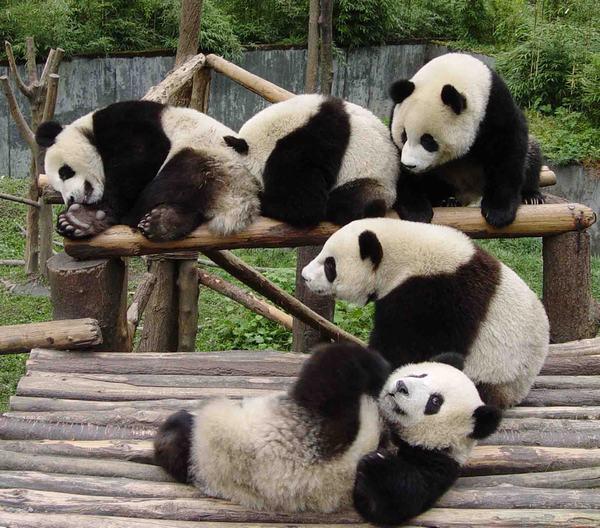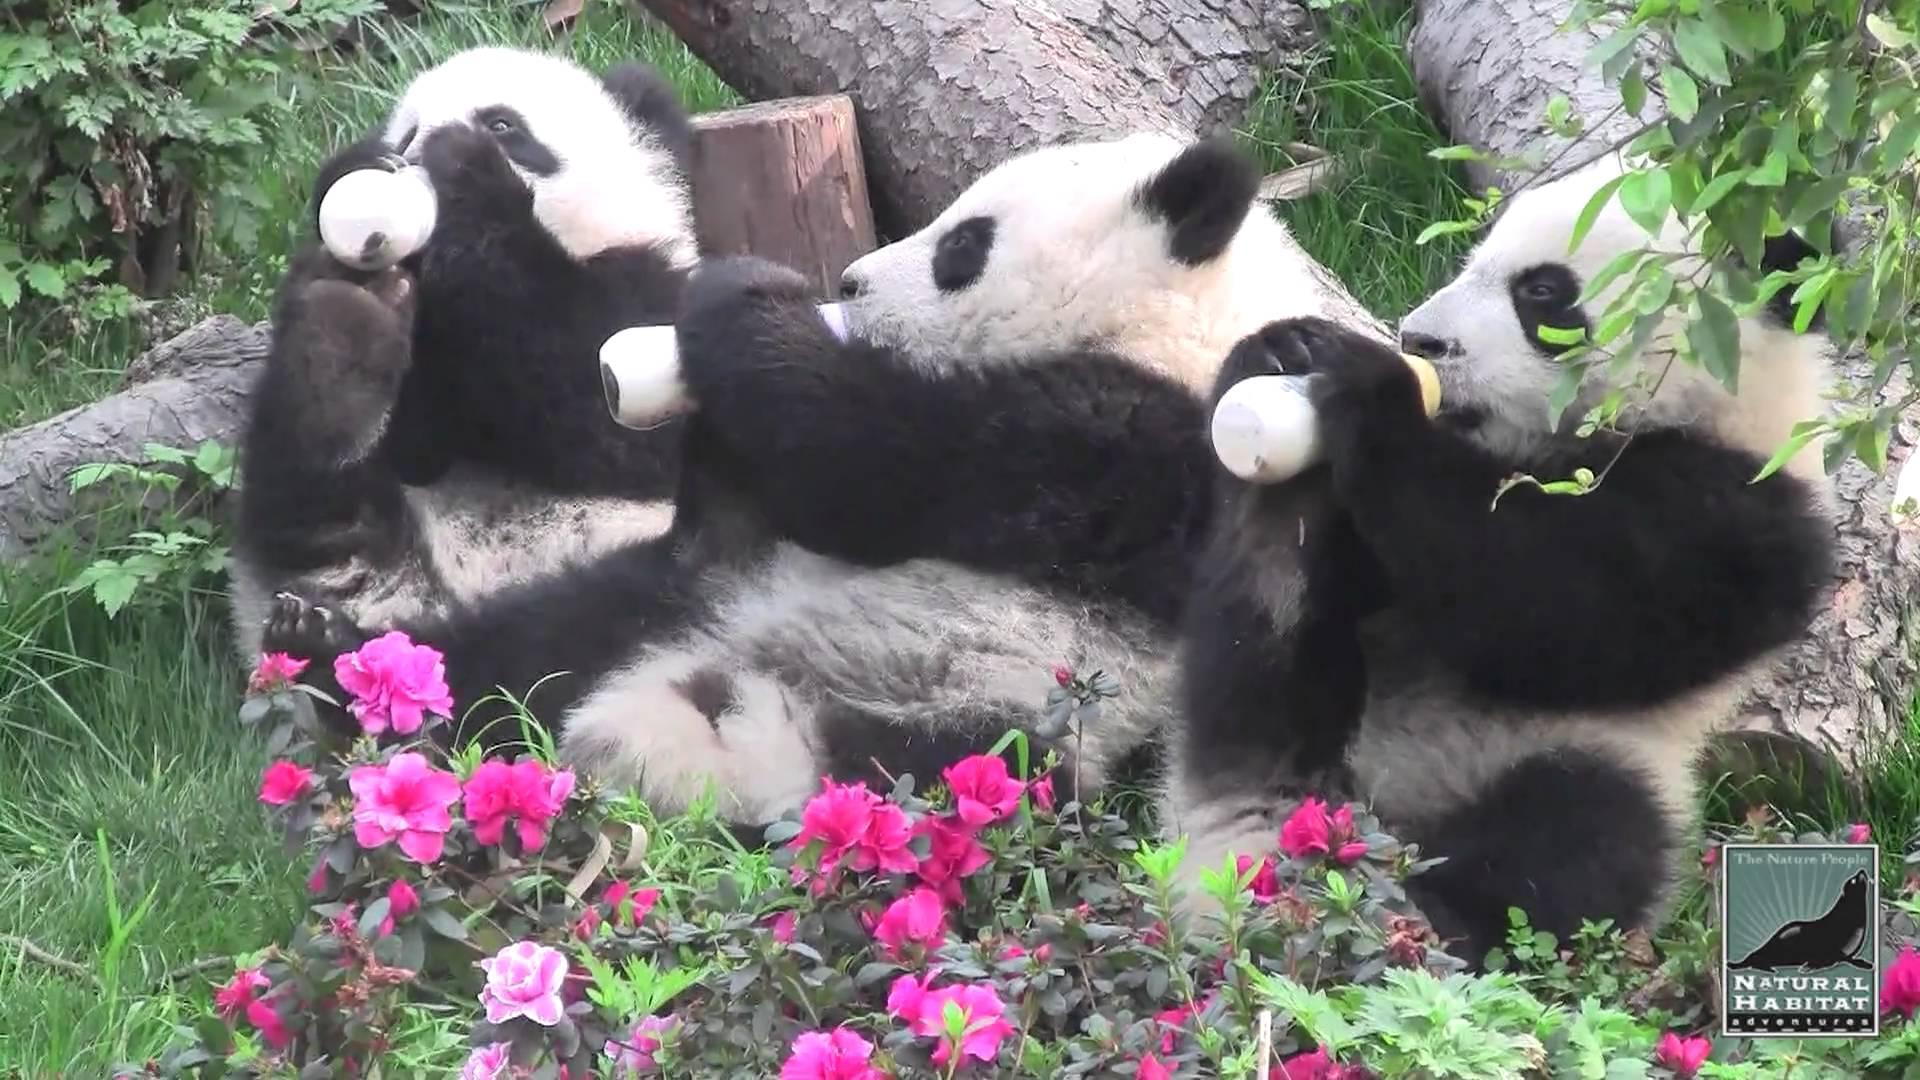The first image is the image on the left, the second image is the image on the right. Given the left and right images, does the statement "There are no more than three panda bears." hold true? Answer yes or no. No. The first image is the image on the left, the second image is the image on the right. For the images shown, is this caption "There are two pandas climbing a branch." true? Answer yes or no. No. 